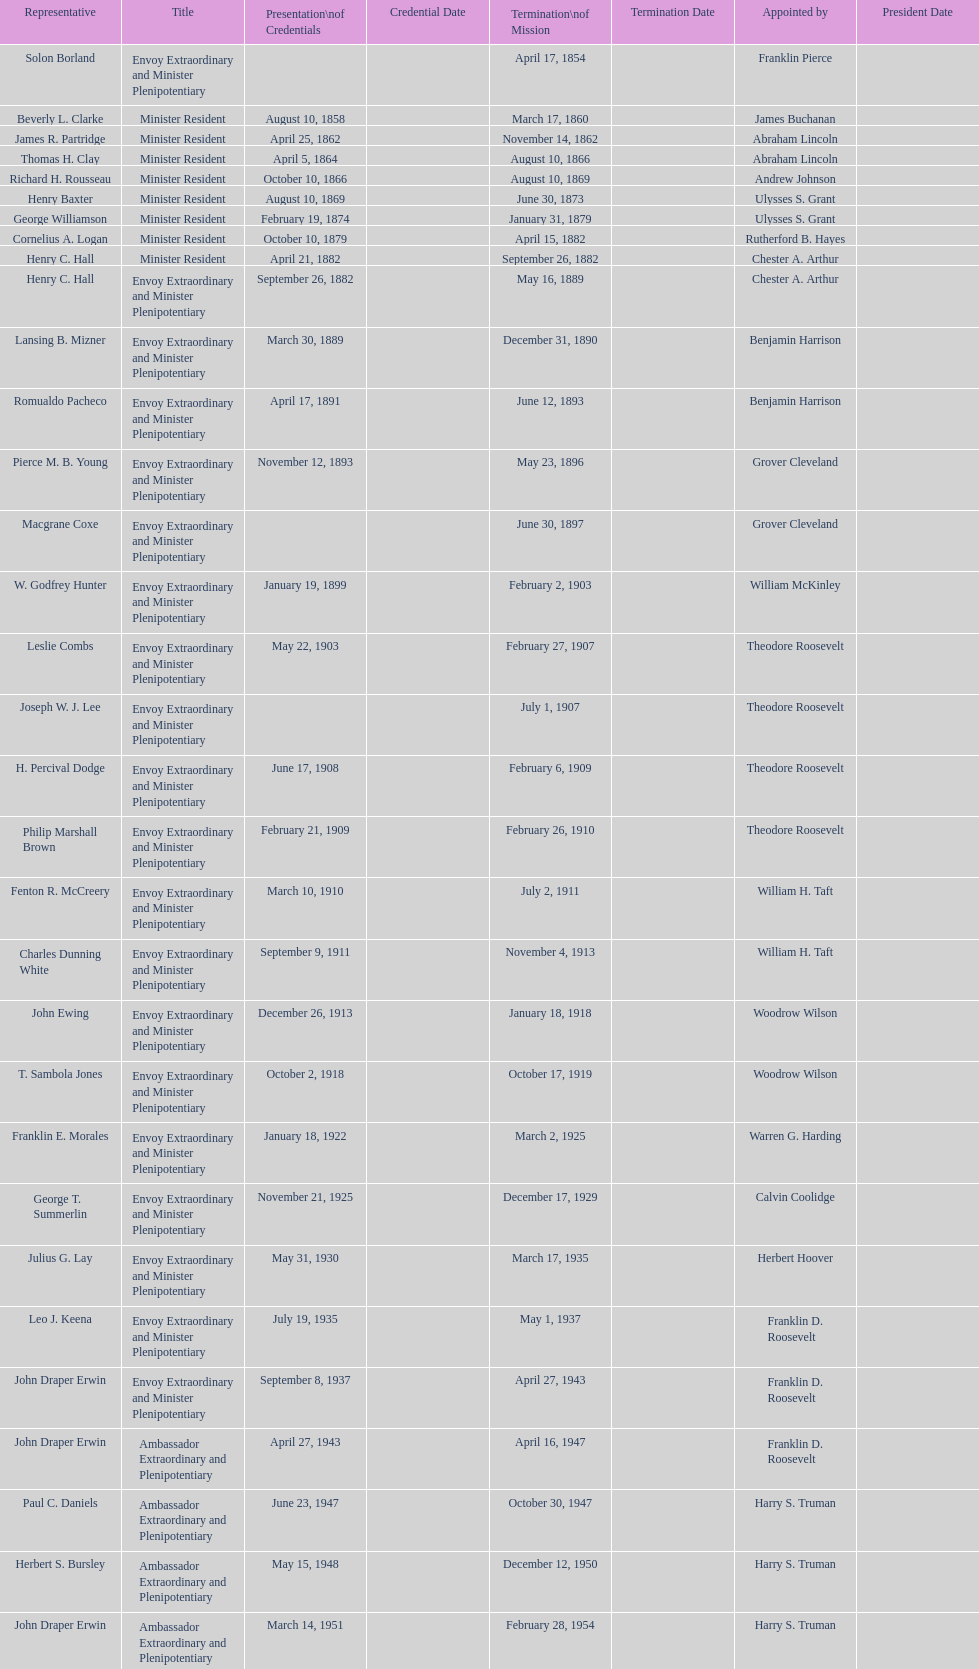Who was the last representative picked? Lisa Kubiske. 